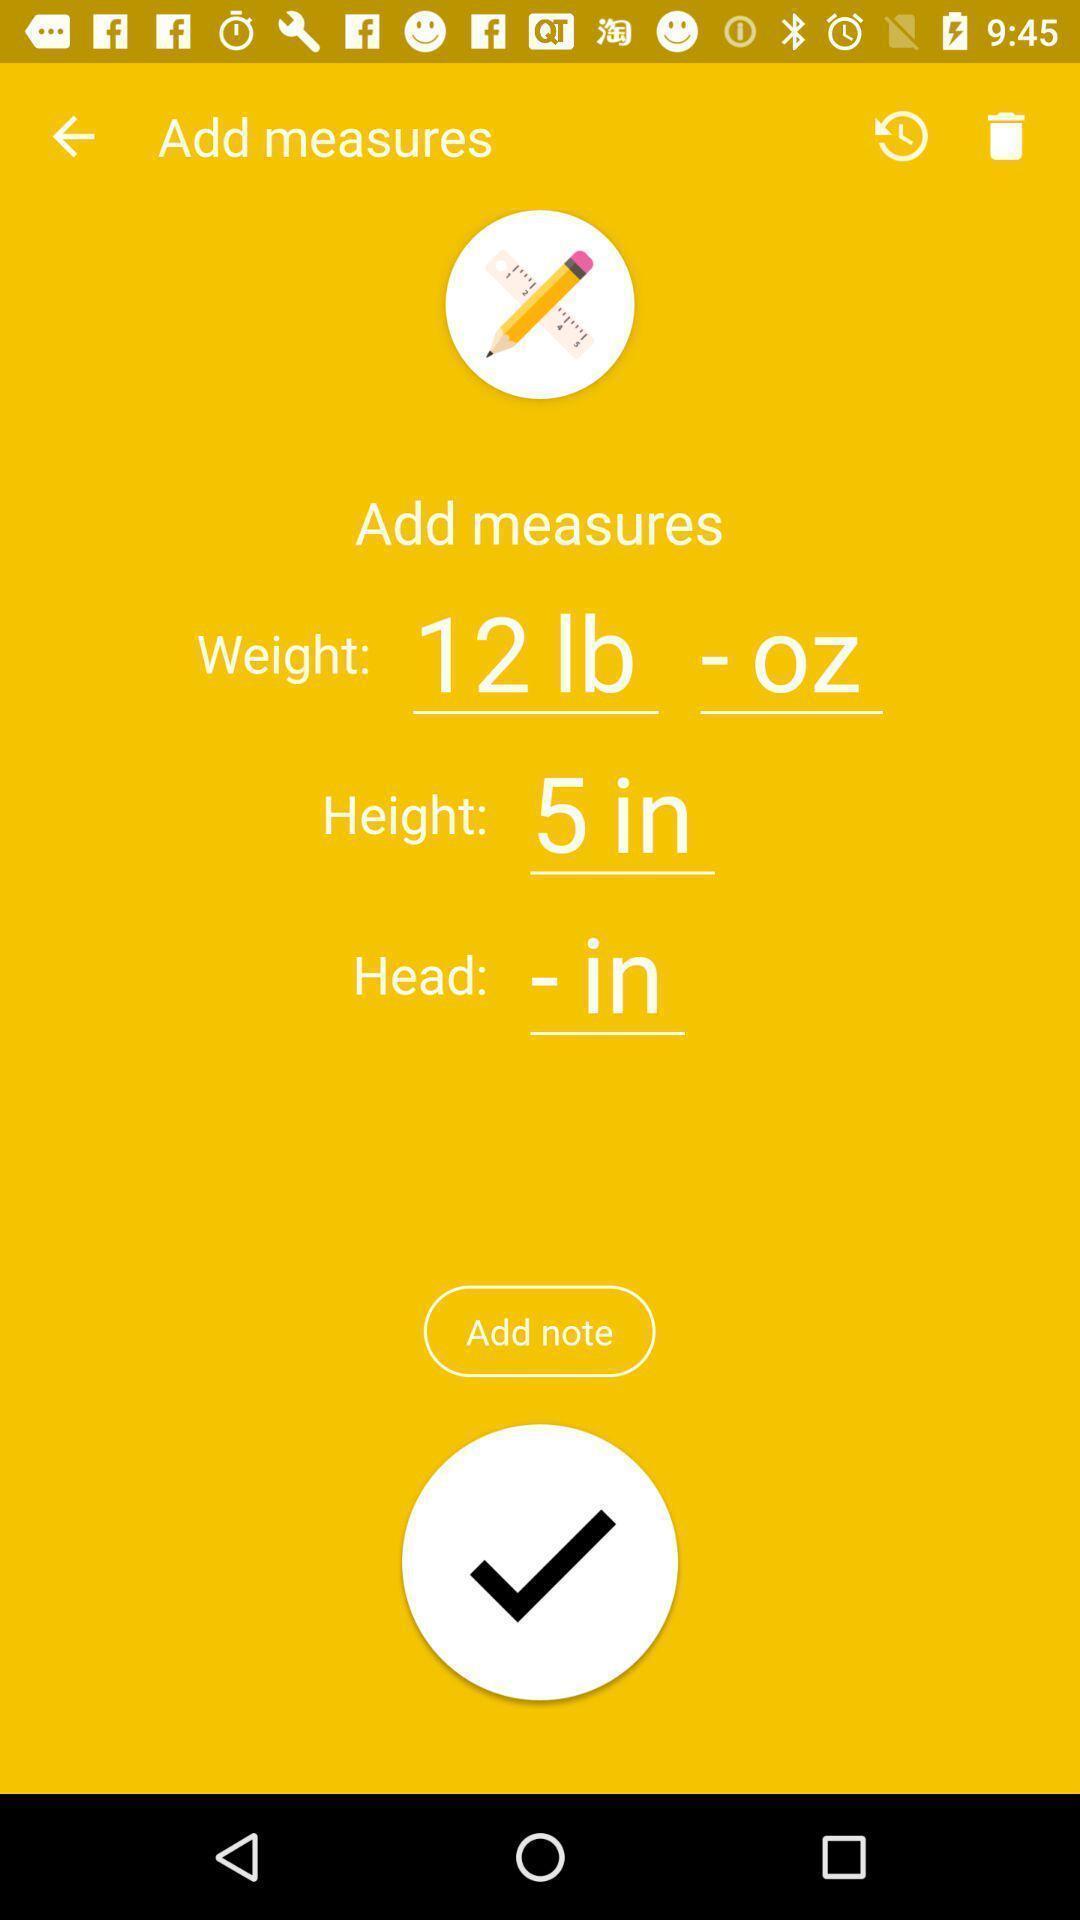Please provide a description for this image. Screen displaying multiple options in notes page. 